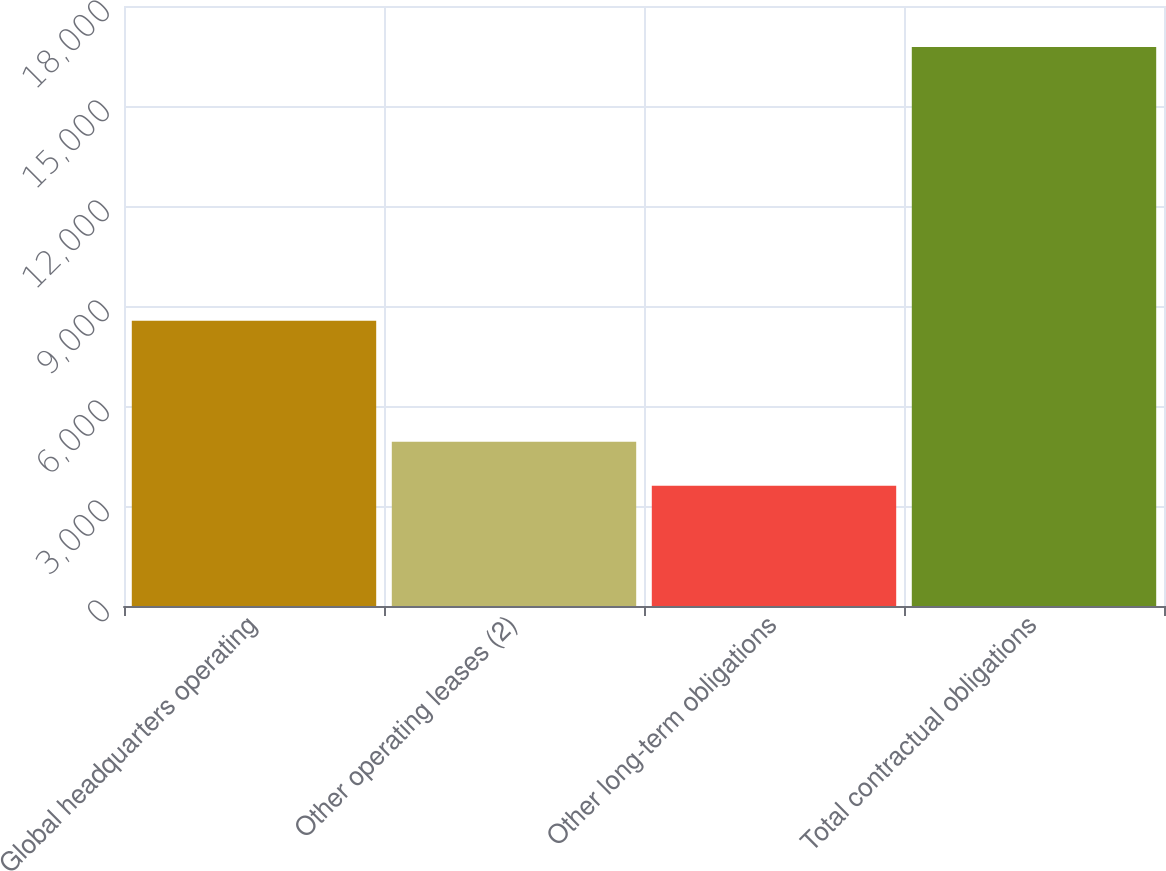<chart> <loc_0><loc_0><loc_500><loc_500><bar_chart><fcel>Global headquarters operating<fcel>Other operating leases (2)<fcel>Other long-term obligations<fcel>Total contractual obligations<nl><fcel>8556<fcel>4926.9<fcel>3611<fcel>16770<nl></chart> 